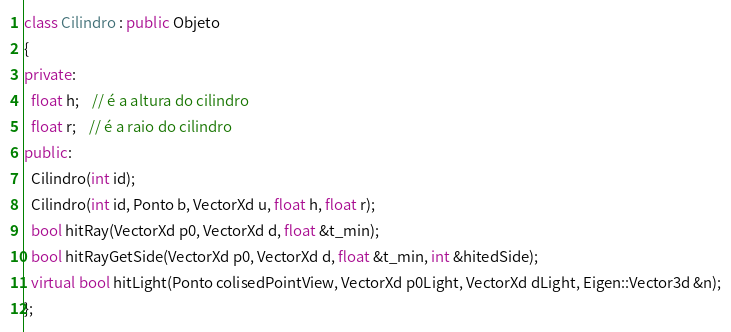<code> <loc_0><loc_0><loc_500><loc_500><_C++_>class Cilindro : public Objeto
{
private:
  float h;    // é a altura do cilindro
  float r;    // é a raio do cilindro
public:
  Cilindro(int id);
  Cilindro(int id, Ponto b, VectorXd u, float h, float r);
  bool hitRay(VectorXd p0, VectorXd d, float &t_min);
  bool hitRayGetSide(VectorXd p0, VectorXd d, float &t_min, int &hitedSide);
  virtual bool hitLight(Ponto colisedPointView, VectorXd p0Light, VectorXd dLight, Eigen::Vector3d &n);
};</code> 